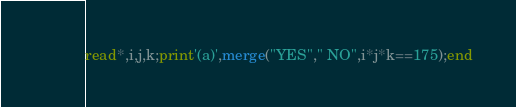Convert code to text. <code><loc_0><loc_0><loc_500><loc_500><_FORTRAN_>read*,i,j,k;print'(a)',merge("YES"," NO",i*j*k==175);end</code> 